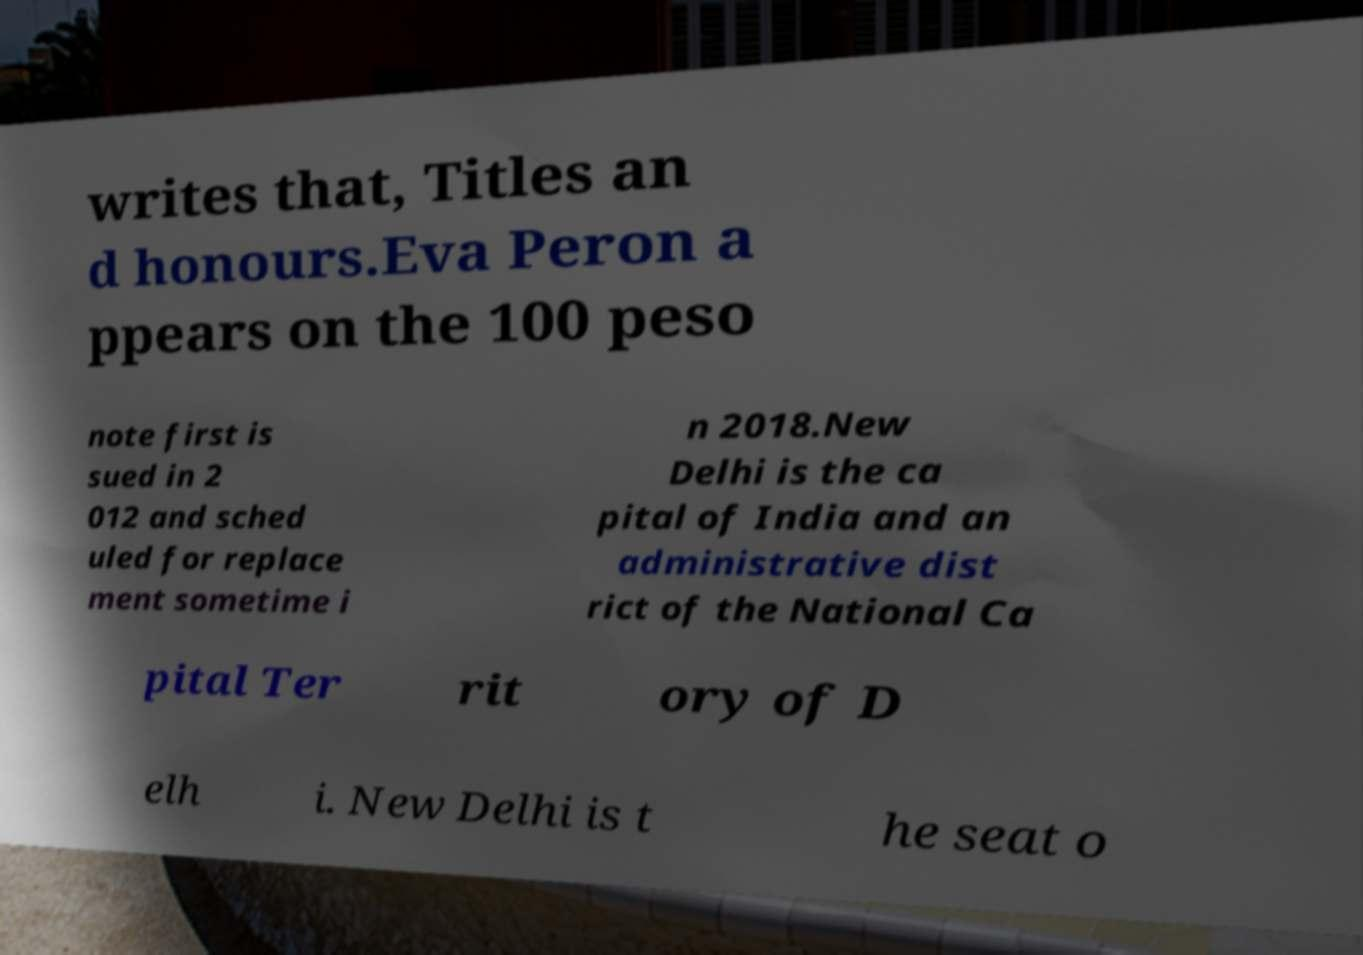For documentation purposes, I need the text within this image transcribed. Could you provide that? writes that, Titles an d honours.Eva Peron a ppears on the 100 peso note first is sued in 2 012 and sched uled for replace ment sometime i n 2018.New Delhi is the ca pital of India and an administrative dist rict of the National Ca pital Ter rit ory of D elh i. New Delhi is t he seat o 